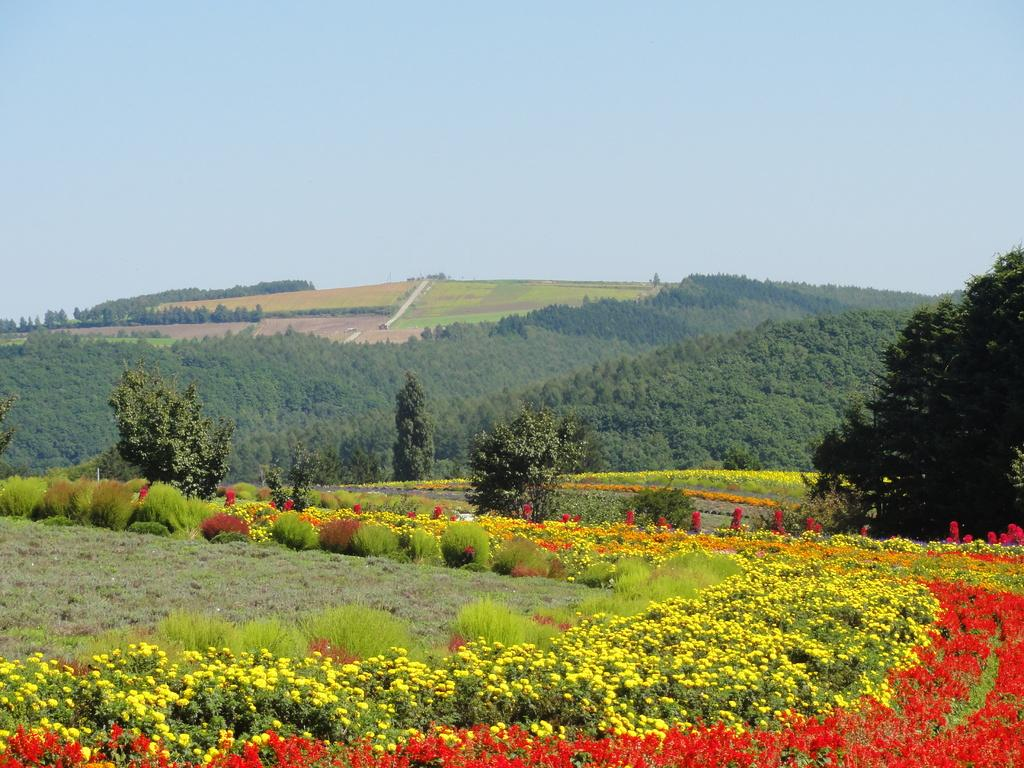What type of living organisms can be seen in the image? Plants can be seen in the image. What specific feature of the plants is visible? The plants have flowers. What colors are the flowers? The flowers are red and yellow in color. What can be seen in the background of the image? Trees and the sky are visible in the background of the image. What type of design can be seen on the quartz in the image? There is no quartz present in the image, so it is not possible to determine the design on any quartz. What language are the flowers speaking in the image? The flowers are not capable of speaking any language, as they are inanimate objects. 